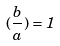<formula> <loc_0><loc_0><loc_500><loc_500>( \frac { b } { a } ) = 1</formula> 